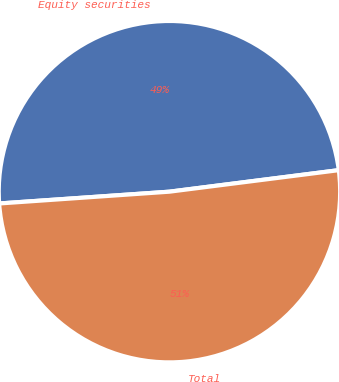Convert chart to OTSL. <chart><loc_0><loc_0><loc_500><loc_500><pie_chart><fcel>Equity securities<fcel>Total<nl><fcel>49.09%<fcel>50.91%<nl></chart> 